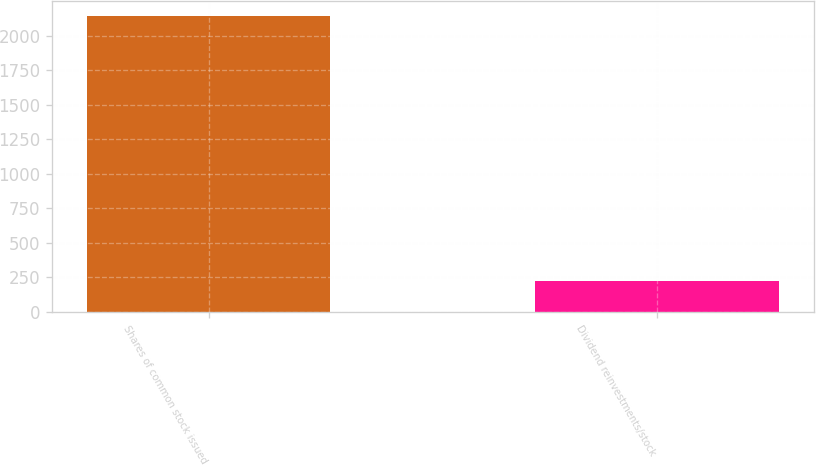Convert chart to OTSL. <chart><loc_0><loc_0><loc_500><loc_500><bar_chart><fcel>Shares of common stock issued<fcel>Dividend reinvestments/stock<nl><fcel>2141<fcel>223<nl></chart> 